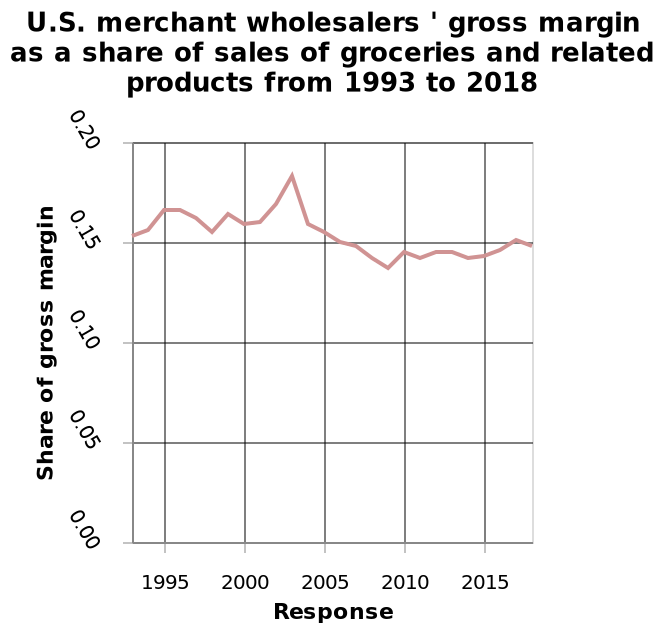<image>
Has there been any significant change in the US merchant wholesalers' gross margin as a share of sales of groceries and related products between 1993 and 2018? No, the gross margin as a share of groceries and related products has remained relatively stable with only a small spike around 2003. What does the y-axis represent in the line diagram? The y-axis represents the "Share of gross margin" in the line diagram. 